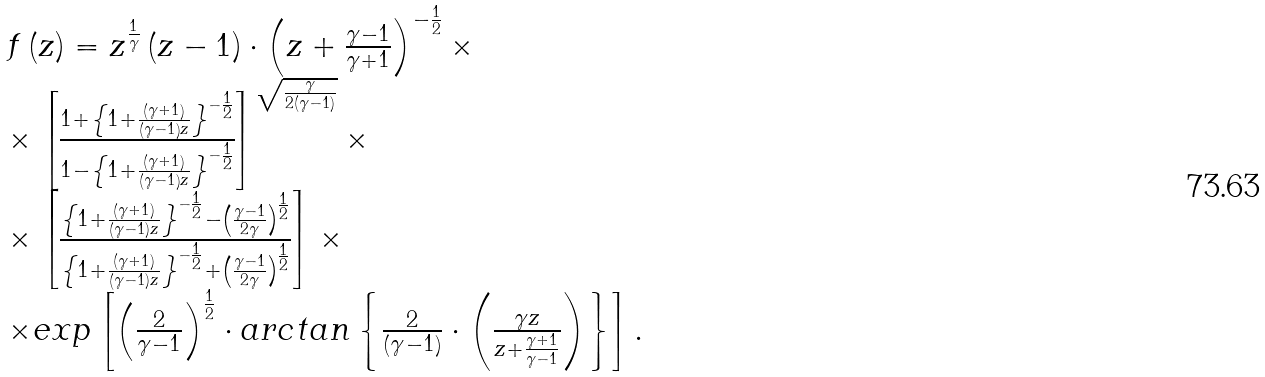Convert formula to latex. <formula><loc_0><loc_0><loc_500><loc_500>\begin{array} { l } f \left ( { z } \right ) = z ^ { \frac { 1 } { \gamma } } \left ( { z - 1 } \right ) \cdot \left ( { z + \frac { \gamma - 1 } { \gamma + 1 } } \right ) ^ { - \frac { 1 } { 2 } } \times \\ \times \left [ { \frac { { 1 + \left \{ { 1 + \frac { { \left ( { \gamma + 1 } \right ) } } { { \left ( { \gamma - 1 } \right ) z } } } \right \} ^ { - \frac { 1 } { 2 } } } } { { 1 - \left \{ { 1 + \frac { { \left ( { \gamma + 1 } \right ) } } { { \left ( { \gamma - 1 } \right ) z } } } \right \} ^ { - \frac { 1 } { 2 } } } } } \right ] ^ { \sqrt { \frac { \gamma } { { 2 \left ( { \gamma - 1 } \right ) } } } } \times \\ \times \left [ { \frac { { \left \{ { 1 + \frac { { \left ( { \gamma + 1 } \right ) } } { { \left ( { \gamma - 1 } \right ) z } } } \right \} ^ { - \frac { 1 } { 2 } } - \left ( { \frac { \gamma - 1 } { 2 \gamma } } \right ) ^ { \frac { 1 } { 2 } } } } { { \left \{ { 1 + \frac { { \left ( { \gamma + 1 } \right ) } } { { \left ( { \gamma - 1 } \right ) z } } } \right \} ^ { - \frac { 1 } { 2 } } + \left ( { \frac { \gamma - 1 } { 2 \gamma } } \right ) ^ { \frac { 1 } { 2 } } } } } \right ] \times \\ \times e x p \left [ { \left ( { \frac { 2 } { \gamma - 1 } } \right ) ^ { \frac { 1 } { 2 } } \cdot a r c t a n \left \{ { \frac { 2 } { { \left ( { \gamma - 1 } \right ) } } \cdot \left ( { \frac { \gamma z } { { z + \frac { \gamma + 1 } { \gamma - 1 } } } } \right ) } \right \} } \right ] . \\ \end{array}</formula> 